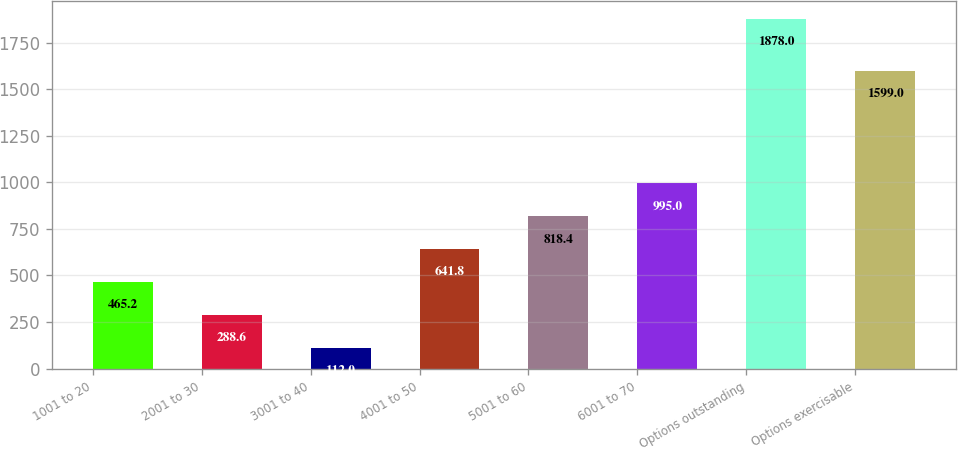Convert chart to OTSL. <chart><loc_0><loc_0><loc_500><loc_500><bar_chart><fcel>1001 to 20<fcel>2001 to 30<fcel>3001 to 40<fcel>4001 to 50<fcel>5001 to 60<fcel>6001 to 70<fcel>Options outstanding<fcel>Options exercisable<nl><fcel>465.2<fcel>288.6<fcel>112<fcel>641.8<fcel>818.4<fcel>995<fcel>1878<fcel>1599<nl></chart> 